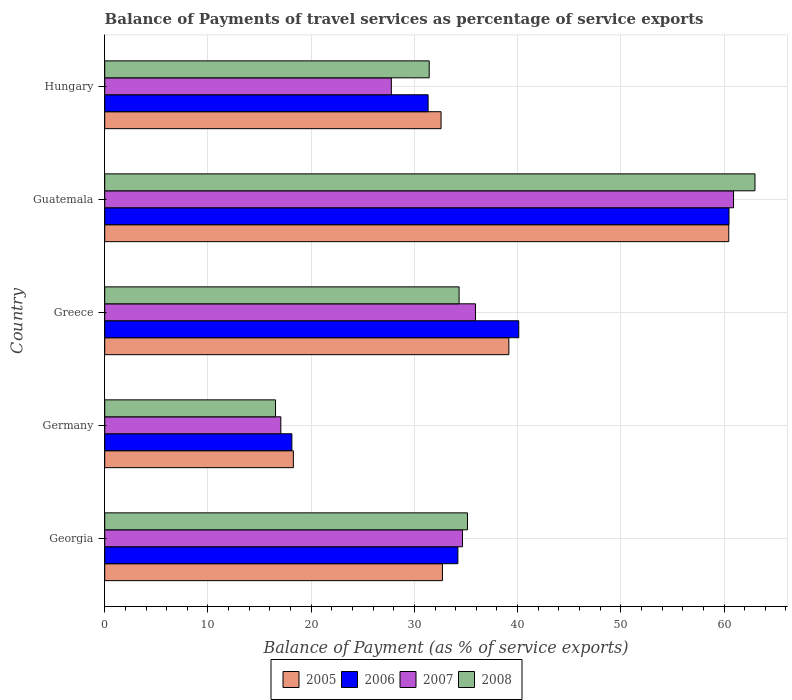Are the number of bars on each tick of the Y-axis equal?
Offer a terse response. Yes. What is the label of the 1st group of bars from the top?
Give a very brief answer. Hungary. In how many cases, is the number of bars for a given country not equal to the number of legend labels?
Your answer should be very brief. 0. What is the balance of payments of travel services in 2005 in Guatemala?
Your answer should be compact. 60.46. Across all countries, what is the maximum balance of payments of travel services in 2008?
Your answer should be compact. 63. Across all countries, what is the minimum balance of payments of travel services in 2008?
Ensure brevity in your answer.  16.55. In which country was the balance of payments of travel services in 2006 maximum?
Your answer should be very brief. Guatemala. What is the total balance of payments of travel services in 2006 in the graph?
Offer a very short reply. 184.28. What is the difference between the balance of payments of travel services in 2007 in Guatemala and that in Hungary?
Provide a short and direct response. 33.15. What is the difference between the balance of payments of travel services in 2005 in Greece and the balance of payments of travel services in 2008 in Hungary?
Ensure brevity in your answer.  7.72. What is the average balance of payments of travel services in 2008 per country?
Provide a short and direct response. 36.09. What is the difference between the balance of payments of travel services in 2008 and balance of payments of travel services in 2006 in Greece?
Ensure brevity in your answer.  -5.78. What is the ratio of the balance of payments of travel services in 2008 in Guatemala to that in Hungary?
Ensure brevity in your answer.  2. Is the difference between the balance of payments of travel services in 2008 in Greece and Guatemala greater than the difference between the balance of payments of travel services in 2006 in Greece and Guatemala?
Your answer should be compact. No. What is the difference between the highest and the second highest balance of payments of travel services in 2007?
Offer a very short reply. 25. What is the difference between the highest and the lowest balance of payments of travel services in 2008?
Provide a succinct answer. 46.45. In how many countries, is the balance of payments of travel services in 2008 greater than the average balance of payments of travel services in 2008 taken over all countries?
Make the answer very short. 1. Is the sum of the balance of payments of travel services in 2006 in Greece and Guatemala greater than the maximum balance of payments of travel services in 2008 across all countries?
Your answer should be very brief. Yes. Is it the case that in every country, the sum of the balance of payments of travel services in 2008 and balance of payments of travel services in 2005 is greater than the sum of balance of payments of travel services in 2007 and balance of payments of travel services in 2006?
Give a very brief answer. No. What does the 3rd bar from the bottom in Hungary represents?
Your response must be concise. 2007. How many bars are there?
Your response must be concise. 20. Are all the bars in the graph horizontal?
Ensure brevity in your answer.  Yes. What is the difference between two consecutive major ticks on the X-axis?
Give a very brief answer. 10. Are the values on the major ticks of X-axis written in scientific E-notation?
Provide a succinct answer. No. Where does the legend appear in the graph?
Make the answer very short. Bottom center. How many legend labels are there?
Offer a terse response. 4. What is the title of the graph?
Your answer should be compact. Balance of Payments of travel services as percentage of service exports. What is the label or title of the X-axis?
Offer a terse response. Balance of Payment (as % of service exports). What is the Balance of Payment (as % of service exports) in 2005 in Georgia?
Your answer should be very brief. 32.72. What is the Balance of Payment (as % of service exports) in 2006 in Georgia?
Your answer should be compact. 34.22. What is the Balance of Payment (as % of service exports) of 2007 in Georgia?
Offer a very short reply. 34.66. What is the Balance of Payment (as % of service exports) of 2008 in Georgia?
Offer a terse response. 35.15. What is the Balance of Payment (as % of service exports) in 2005 in Germany?
Keep it short and to the point. 18.28. What is the Balance of Payment (as % of service exports) of 2006 in Germany?
Make the answer very short. 18.13. What is the Balance of Payment (as % of service exports) of 2007 in Germany?
Offer a terse response. 17.06. What is the Balance of Payment (as % of service exports) in 2008 in Germany?
Offer a terse response. 16.55. What is the Balance of Payment (as % of service exports) of 2005 in Greece?
Your answer should be very brief. 39.16. What is the Balance of Payment (as % of service exports) of 2006 in Greece?
Keep it short and to the point. 40.11. What is the Balance of Payment (as % of service exports) of 2007 in Greece?
Your answer should be very brief. 35.92. What is the Balance of Payment (as % of service exports) in 2008 in Greece?
Ensure brevity in your answer.  34.33. What is the Balance of Payment (as % of service exports) in 2005 in Guatemala?
Keep it short and to the point. 60.46. What is the Balance of Payment (as % of service exports) in 2006 in Guatemala?
Your response must be concise. 60.48. What is the Balance of Payment (as % of service exports) of 2007 in Guatemala?
Your response must be concise. 60.92. What is the Balance of Payment (as % of service exports) in 2008 in Guatemala?
Provide a short and direct response. 63. What is the Balance of Payment (as % of service exports) of 2005 in Hungary?
Give a very brief answer. 32.59. What is the Balance of Payment (as % of service exports) of 2006 in Hungary?
Give a very brief answer. 31.33. What is the Balance of Payment (as % of service exports) in 2007 in Hungary?
Give a very brief answer. 27.77. What is the Balance of Payment (as % of service exports) in 2008 in Hungary?
Provide a short and direct response. 31.44. Across all countries, what is the maximum Balance of Payment (as % of service exports) of 2005?
Offer a terse response. 60.46. Across all countries, what is the maximum Balance of Payment (as % of service exports) in 2006?
Keep it short and to the point. 60.48. Across all countries, what is the maximum Balance of Payment (as % of service exports) in 2007?
Offer a terse response. 60.92. Across all countries, what is the maximum Balance of Payment (as % of service exports) of 2008?
Make the answer very short. 63. Across all countries, what is the minimum Balance of Payment (as % of service exports) in 2005?
Give a very brief answer. 18.28. Across all countries, what is the minimum Balance of Payment (as % of service exports) of 2006?
Offer a terse response. 18.13. Across all countries, what is the minimum Balance of Payment (as % of service exports) in 2007?
Keep it short and to the point. 17.06. Across all countries, what is the minimum Balance of Payment (as % of service exports) in 2008?
Your answer should be compact. 16.55. What is the total Balance of Payment (as % of service exports) of 2005 in the graph?
Offer a very short reply. 183.2. What is the total Balance of Payment (as % of service exports) in 2006 in the graph?
Keep it short and to the point. 184.28. What is the total Balance of Payment (as % of service exports) of 2007 in the graph?
Give a very brief answer. 176.34. What is the total Balance of Payment (as % of service exports) of 2008 in the graph?
Provide a succinct answer. 180.47. What is the difference between the Balance of Payment (as % of service exports) of 2005 in Georgia and that in Germany?
Offer a terse response. 14.44. What is the difference between the Balance of Payment (as % of service exports) in 2006 in Georgia and that in Germany?
Provide a short and direct response. 16.08. What is the difference between the Balance of Payment (as % of service exports) of 2007 in Georgia and that in Germany?
Offer a very short reply. 17.6. What is the difference between the Balance of Payment (as % of service exports) in 2008 in Georgia and that in Germany?
Ensure brevity in your answer.  18.6. What is the difference between the Balance of Payment (as % of service exports) in 2005 in Georgia and that in Greece?
Keep it short and to the point. -6.44. What is the difference between the Balance of Payment (as % of service exports) in 2006 in Georgia and that in Greece?
Keep it short and to the point. -5.9. What is the difference between the Balance of Payment (as % of service exports) of 2007 in Georgia and that in Greece?
Keep it short and to the point. -1.26. What is the difference between the Balance of Payment (as % of service exports) in 2008 in Georgia and that in Greece?
Make the answer very short. 0.81. What is the difference between the Balance of Payment (as % of service exports) in 2005 in Georgia and that in Guatemala?
Your answer should be compact. -27.74. What is the difference between the Balance of Payment (as % of service exports) of 2006 in Georgia and that in Guatemala?
Provide a succinct answer. -26.27. What is the difference between the Balance of Payment (as % of service exports) of 2007 in Georgia and that in Guatemala?
Your answer should be very brief. -26.26. What is the difference between the Balance of Payment (as % of service exports) of 2008 in Georgia and that in Guatemala?
Make the answer very short. -27.86. What is the difference between the Balance of Payment (as % of service exports) in 2005 in Georgia and that in Hungary?
Provide a short and direct response. 0.13. What is the difference between the Balance of Payment (as % of service exports) in 2006 in Georgia and that in Hungary?
Give a very brief answer. 2.88. What is the difference between the Balance of Payment (as % of service exports) of 2007 in Georgia and that in Hungary?
Provide a short and direct response. 6.89. What is the difference between the Balance of Payment (as % of service exports) of 2008 in Georgia and that in Hungary?
Ensure brevity in your answer.  3.71. What is the difference between the Balance of Payment (as % of service exports) in 2005 in Germany and that in Greece?
Give a very brief answer. -20.88. What is the difference between the Balance of Payment (as % of service exports) of 2006 in Germany and that in Greece?
Offer a very short reply. -21.98. What is the difference between the Balance of Payment (as % of service exports) of 2007 in Germany and that in Greece?
Offer a terse response. -18.86. What is the difference between the Balance of Payment (as % of service exports) of 2008 in Germany and that in Greece?
Provide a short and direct response. -17.78. What is the difference between the Balance of Payment (as % of service exports) in 2005 in Germany and that in Guatemala?
Give a very brief answer. -42.18. What is the difference between the Balance of Payment (as % of service exports) of 2006 in Germany and that in Guatemala?
Your answer should be very brief. -42.35. What is the difference between the Balance of Payment (as % of service exports) in 2007 in Germany and that in Guatemala?
Offer a very short reply. -43.86. What is the difference between the Balance of Payment (as % of service exports) of 2008 in Germany and that in Guatemala?
Your response must be concise. -46.45. What is the difference between the Balance of Payment (as % of service exports) in 2005 in Germany and that in Hungary?
Your answer should be very brief. -14.31. What is the difference between the Balance of Payment (as % of service exports) in 2006 in Germany and that in Hungary?
Provide a succinct answer. -13.2. What is the difference between the Balance of Payment (as % of service exports) of 2007 in Germany and that in Hungary?
Make the answer very short. -10.71. What is the difference between the Balance of Payment (as % of service exports) of 2008 in Germany and that in Hungary?
Your response must be concise. -14.89. What is the difference between the Balance of Payment (as % of service exports) in 2005 in Greece and that in Guatemala?
Your answer should be very brief. -21.31. What is the difference between the Balance of Payment (as % of service exports) of 2006 in Greece and that in Guatemala?
Provide a succinct answer. -20.37. What is the difference between the Balance of Payment (as % of service exports) of 2007 in Greece and that in Guatemala?
Provide a short and direct response. -25. What is the difference between the Balance of Payment (as % of service exports) in 2008 in Greece and that in Guatemala?
Give a very brief answer. -28.67. What is the difference between the Balance of Payment (as % of service exports) in 2005 in Greece and that in Hungary?
Make the answer very short. 6.57. What is the difference between the Balance of Payment (as % of service exports) in 2006 in Greece and that in Hungary?
Make the answer very short. 8.78. What is the difference between the Balance of Payment (as % of service exports) of 2007 in Greece and that in Hungary?
Provide a succinct answer. 8.15. What is the difference between the Balance of Payment (as % of service exports) in 2008 in Greece and that in Hungary?
Your answer should be very brief. 2.9. What is the difference between the Balance of Payment (as % of service exports) of 2005 in Guatemala and that in Hungary?
Your response must be concise. 27.87. What is the difference between the Balance of Payment (as % of service exports) of 2006 in Guatemala and that in Hungary?
Ensure brevity in your answer.  29.15. What is the difference between the Balance of Payment (as % of service exports) in 2007 in Guatemala and that in Hungary?
Provide a short and direct response. 33.15. What is the difference between the Balance of Payment (as % of service exports) of 2008 in Guatemala and that in Hungary?
Offer a very short reply. 31.56. What is the difference between the Balance of Payment (as % of service exports) in 2005 in Georgia and the Balance of Payment (as % of service exports) in 2006 in Germany?
Give a very brief answer. 14.59. What is the difference between the Balance of Payment (as % of service exports) in 2005 in Georgia and the Balance of Payment (as % of service exports) in 2007 in Germany?
Make the answer very short. 15.66. What is the difference between the Balance of Payment (as % of service exports) in 2005 in Georgia and the Balance of Payment (as % of service exports) in 2008 in Germany?
Your answer should be compact. 16.17. What is the difference between the Balance of Payment (as % of service exports) of 2006 in Georgia and the Balance of Payment (as % of service exports) of 2007 in Germany?
Give a very brief answer. 17.15. What is the difference between the Balance of Payment (as % of service exports) in 2006 in Georgia and the Balance of Payment (as % of service exports) in 2008 in Germany?
Your answer should be compact. 17.67. What is the difference between the Balance of Payment (as % of service exports) in 2007 in Georgia and the Balance of Payment (as % of service exports) in 2008 in Germany?
Offer a very short reply. 18.12. What is the difference between the Balance of Payment (as % of service exports) of 2005 in Georgia and the Balance of Payment (as % of service exports) of 2006 in Greece?
Offer a very short reply. -7.39. What is the difference between the Balance of Payment (as % of service exports) of 2005 in Georgia and the Balance of Payment (as % of service exports) of 2007 in Greece?
Give a very brief answer. -3.2. What is the difference between the Balance of Payment (as % of service exports) of 2005 in Georgia and the Balance of Payment (as % of service exports) of 2008 in Greece?
Your answer should be very brief. -1.61. What is the difference between the Balance of Payment (as % of service exports) of 2006 in Georgia and the Balance of Payment (as % of service exports) of 2007 in Greece?
Ensure brevity in your answer.  -1.7. What is the difference between the Balance of Payment (as % of service exports) of 2006 in Georgia and the Balance of Payment (as % of service exports) of 2008 in Greece?
Provide a short and direct response. -0.12. What is the difference between the Balance of Payment (as % of service exports) in 2007 in Georgia and the Balance of Payment (as % of service exports) in 2008 in Greece?
Ensure brevity in your answer.  0.33. What is the difference between the Balance of Payment (as % of service exports) of 2005 in Georgia and the Balance of Payment (as % of service exports) of 2006 in Guatemala?
Offer a very short reply. -27.76. What is the difference between the Balance of Payment (as % of service exports) of 2005 in Georgia and the Balance of Payment (as % of service exports) of 2007 in Guatemala?
Your response must be concise. -28.2. What is the difference between the Balance of Payment (as % of service exports) of 2005 in Georgia and the Balance of Payment (as % of service exports) of 2008 in Guatemala?
Ensure brevity in your answer.  -30.28. What is the difference between the Balance of Payment (as % of service exports) in 2006 in Georgia and the Balance of Payment (as % of service exports) in 2007 in Guatemala?
Provide a succinct answer. -26.71. What is the difference between the Balance of Payment (as % of service exports) of 2006 in Georgia and the Balance of Payment (as % of service exports) of 2008 in Guatemala?
Keep it short and to the point. -28.78. What is the difference between the Balance of Payment (as % of service exports) of 2007 in Georgia and the Balance of Payment (as % of service exports) of 2008 in Guatemala?
Provide a short and direct response. -28.34. What is the difference between the Balance of Payment (as % of service exports) in 2005 in Georgia and the Balance of Payment (as % of service exports) in 2006 in Hungary?
Your answer should be compact. 1.39. What is the difference between the Balance of Payment (as % of service exports) in 2005 in Georgia and the Balance of Payment (as % of service exports) in 2007 in Hungary?
Ensure brevity in your answer.  4.95. What is the difference between the Balance of Payment (as % of service exports) in 2005 in Georgia and the Balance of Payment (as % of service exports) in 2008 in Hungary?
Keep it short and to the point. 1.28. What is the difference between the Balance of Payment (as % of service exports) of 2006 in Georgia and the Balance of Payment (as % of service exports) of 2007 in Hungary?
Provide a short and direct response. 6.45. What is the difference between the Balance of Payment (as % of service exports) of 2006 in Georgia and the Balance of Payment (as % of service exports) of 2008 in Hungary?
Your answer should be very brief. 2.78. What is the difference between the Balance of Payment (as % of service exports) in 2007 in Georgia and the Balance of Payment (as % of service exports) in 2008 in Hungary?
Your response must be concise. 3.23. What is the difference between the Balance of Payment (as % of service exports) of 2005 in Germany and the Balance of Payment (as % of service exports) of 2006 in Greece?
Make the answer very short. -21.84. What is the difference between the Balance of Payment (as % of service exports) in 2005 in Germany and the Balance of Payment (as % of service exports) in 2007 in Greece?
Give a very brief answer. -17.64. What is the difference between the Balance of Payment (as % of service exports) in 2005 in Germany and the Balance of Payment (as % of service exports) in 2008 in Greece?
Give a very brief answer. -16.06. What is the difference between the Balance of Payment (as % of service exports) of 2006 in Germany and the Balance of Payment (as % of service exports) of 2007 in Greece?
Keep it short and to the point. -17.79. What is the difference between the Balance of Payment (as % of service exports) of 2006 in Germany and the Balance of Payment (as % of service exports) of 2008 in Greece?
Provide a succinct answer. -16.2. What is the difference between the Balance of Payment (as % of service exports) of 2007 in Germany and the Balance of Payment (as % of service exports) of 2008 in Greece?
Make the answer very short. -17.27. What is the difference between the Balance of Payment (as % of service exports) of 2005 in Germany and the Balance of Payment (as % of service exports) of 2006 in Guatemala?
Your response must be concise. -42.21. What is the difference between the Balance of Payment (as % of service exports) in 2005 in Germany and the Balance of Payment (as % of service exports) in 2007 in Guatemala?
Provide a succinct answer. -42.65. What is the difference between the Balance of Payment (as % of service exports) in 2005 in Germany and the Balance of Payment (as % of service exports) in 2008 in Guatemala?
Offer a very short reply. -44.72. What is the difference between the Balance of Payment (as % of service exports) in 2006 in Germany and the Balance of Payment (as % of service exports) in 2007 in Guatemala?
Offer a terse response. -42.79. What is the difference between the Balance of Payment (as % of service exports) in 2006 in Germany and the Balance of Payment (as % of service exports) in 2008 in Guatemala?
Offer a terse response. -44.87. What is the difference between the Balance of Payment (as % of service exports) of 2007 in Germany and the Balance of Payment (as % of service exports) of 2008 in Guatemala?
Offer a very short reply. -45.94. What is the difference between the Balance of Payment (as % of service exports) of 2005 in Germany and the Balance of Payment (as % of service exports) of 2006 in Hungary?
Offer a terse response. -13.06. What is the difference between the Balance of Payment (as % of service exports) of 2005 in Germany and the Balance of Payment (as % of service exports) of 2007 in Hungary?
Provide a short and direct response. -9.49. What is the difference between the Balance of Payment (as % of service exports) in 2005 in Germany and the Balance of Payment (as % of service exports) in 2008 in Hungary?
Offer a terse response. -13.16. What is the difference between the Balance of Payment (as % of service exports) of 2006 in Germany and the Balance of Payment (as % of service exports) of 2007 in Hungary?
Your response must be concise. -9.64. What is the difference between the Balance of Payment (as % of service exports) in 2006 in Germany and the Balance of Payment (as % of service exports) in 2008 in Hungary?
Keep it short and to the point. -13.31. What is the difference between the Balance of Payment (as % of service exports) of 2007 in Germany and the Balance of Payment (as % of service exports) of 2008 in Hungary?
Provide a succinct answer. -14.38. What is the difference between the Balance of Payment (as % of service exports) in 2005 in Greece and the Balance of Payment (as % of service exports) in 2006 in Guatemala?
Keep it short and to the point. -21.33. What is the difference between the Balance of Payment (as % of service exports) of 2005 in Greece and the Balance of Payment (as % of service exports) of 2007 in Guatemala?
Keep it short and to the point. -21.77. What is the difference between the Balance of Payment (as % of service exports) of 2005 in Greece and the Balance of Payment (as % of service exports) of 2008 in Guatemala?
Keep it short and to the point. -23.84. What is the difference between the Balance of Payment (as % of service exports) of 2006 in Greece and the Balance of Payment (as % of service exports) of 2007 in Guatemala?
Provide a succinct answer. -20.81. What is the difference between the Balance of Payment (as % of service exports) in 2006 in Greece and the Balance of Payment (as % of service exports) in 2008 in Guatemala?
Your answer should be compact. -22.89. What is the difference between the Balance of Payment (as % of service exports) in 2007 in Greece and the Balance of Payment (as % of service exports) in 2008 in Guatemala?
Provide a short and direct response. -27.08. What is the difference between the Balance of Payment (as % of service exports) in 2005 in Greece and the Balance of Payment (as % of service exports) in 2006 in Hungary?
Your answer should be compact. 7.82. What is the difference between the Balance of Payment (as % of service exports) of 2005 in Greece and the Balance of Payment (as % of service exports) of 2007 in Hungary?
Give a very brief answer. 11.39. What is the difference between the Balance of Payment (as % of service exports) in 2005 in Greece and the Balance of Payment (as % of service exports) in 2008 in Hungary?
Give a very brief answer. 7.72. What is the difference between the Balance of Payment (as % of service exports) in 2006 in Greece and the Balance of Payment (as % of service exports) in 2007 in Hungary?
Keep it short and to the point. 12.34. What is the difference between the Balance of Payment (as % of service exports) in 2006 in Greece and the Balance of Payment (as % of service exports) in 2008 in Hungary?
Offer a terse response. 8.68. What is the difference between the Balance of Payment (as % of service exports) of 2007 in Greece and the Balance of Payment (as % of service exports) of 2008 in Hungary?
Provide a succinct answer. 4.48. What is the difference between the Balance of Payment (as % of service exports) in 2005 in Guatemala and the Balance of Payment (as % of service exports) in 2006 in Hungary?
Your response must be concise. 29.13. What is the difference between the Balance of Payment (as % of service exports) in 2005 in Guatemala and the Balance of Payment (as % of service exports) in 2007 in Hungary?
Make the answer very short. 32.69. What is the difference between the Balance of Payment (as % of service exports) of 2005 in Guatemala and the Balance of Payment (as % of service exports) of 2008 in Hungary?
Your answer should be compact. 29.02. What is the difference between the Balance of Payment (as % of service exports) in 2006 in Guatemala and the Balance of Payment (as % of service exports) in 2007 in Hungary?
Make the answer very short. 32.71. What is the difference between the Balance of Payment (as % of service exports) of 2006 in Guatemala and the Balance of Payment (as % of service exports) of 2008 in Hungary?
Provide a succinct answer. 29.05. What is the difference between the Balance of Payment (as % of service exports) in 2007 in Guatemala and the Balance of Payment (as % of service exports) in 2008 in Hungary?
Ensure brevity in your answer.  29.49. What is the average Balance of Payment (as % of service exports) in 2005 per country?
Provide a succinct answer. 36.64. What is the average Balance of Payment (as % of service exports) of 2006 per country?
Offer a very short reply. 36.86. What is the average Balance of Payment (as % of service exports) of 2007 per country?
Your answer should be very brief. 35.27. What is the average Balance of Payment (as % of service exports) of 2008 per country?
Ensure brevity in your answer.  36.09. What is the difference between the Balance of Payment (as % of service exports) of 2005 and Balance of Payment (as % of service exports) of 2006 in Georgia?
Provide a short and direct response. -1.5. What is the difference between the Balance of Payment (as % of service exports) of 2005 and Balance of Payment (as % of service exports) of 2007 in Georgia?
Your response must be concise. -1.94. What is the difference between the Balance of Payment (as % of service exports) in 2005 and Balance of Payment (as % of service exports) in 2008 in Georgia?
Your answer should be compact. -2.43. What is the difference between the Balance of Payment (as % of service exports) in 2006 and Balance of Payment (as % of service exports) in 2007 in Georgia?
Ensure brevity in your answer.  -0.45. What is the difference between the Balance of Payment (as % of service exports) in 2006 and Balance of Payment (as % of service exports) in 2008 in Georgia?
Provide a short and direct response. -0.93. What is the difference between the Balance of Payment (as % of service exports) of 2007 and Balance of Payment (as % of service exports) of 2008 in Georgia?
Your answer should be very brief. -0.48. What is the difference between the Balance of Payment (as % of service exports) in 2005 and Balance of Payment (as % of service exports) in 2006 in Germany?
Your answer should be very brief. 0.14. What is the difference between the Balance of Payment (as % of service exports) in 2005 and Balance of Payment (as % of service exports) in 2007 in Germany?
Provide a succinct answer. 1.21. What is the difference between the Balance of Payment (as % of service exports) of 2005 and Balance of Payment (as % of service exports) of 2008 in Germany?
Provide a short and direct response. 1.73. What is the difference between the Balance of Payment (as % of service exports) in 2006 and Balance of Payment (as % of service exports) in 2007 in Germany?
Provide a short and direct response. 1.07. What is the difference between the Balance of Payment (as % of service exports) of 2006 and Balance of Payment (as % of service exports) of 2008 in Germany?
Offer a terse response. 1.58. What is the difference between the Balance of Payment (as % of service exports) in 2007 and Balance of Payment (as % of service exports) in 2008 in Germany?
Give a very brief answer. 0.51. What is the difference between the Balance of Payment (as % of service exports) of 2005 and Balance of Payment (as % of service exports) of 2006 in Greece?
Provide a short and direct response. -0.96. What is the difference between the Balance of Payment (as % of service exports) in 2005 and Balance of Payment (as % of service exports) in 2007 in Greece?
Provide a short and direct response. 3.23. What is the difference between the Balance of Payment (as % of service exports) of 2005 and Balance of Payment (as % of service exports) of 2008 in Greece?
Provide a short and direct response. 4.82. What is the difference between the Balance of Payment (as % of service exports) in 2006 and Balance of Payment (as % of service exports) in 2007 in Greece?
Ensure brevity in your answer.  4.19. What is the difference between the Balance of Payment (as % of service exports) in 2006 and Balance of Payment (as % of service exports) in 2008 in Greece?
Provide a succinct answer. 5.78. What is the difference between the Balance of Payment (as % of service exports) in 2007 and Balance of Payment (as % of service exports) in 2008 in Greece?
Ensure brevity in your answer.  1.59. What is the difference between the Balance of Payment (as % of service exports) in 2005 and Balance of Payment (as % of service exports) in 2006 in Guatemala?
Provide a succinct answer. -0.02. What is the difference between the Balance of Payment (as % of service exports) in 2005 and Balance of Payment (as % of service exports) in 2007 in Guatemala?
Your response must be concise. -0.46. What is the difference between the Balance of Payment (as % of service exports) in 2005 and Balance of Payment (as % of service exports) in 2008 in Guatemala?
Your answer should be very brief. -2.54. What is the difference between the Balance of Payment (as % of service exports) in 2006 and Balance of Payment (as % of service exports) in 2007 in Guatemala?
Your response must be concise. -0.44. What is the difference between the Balance of Payment (as % of service exports) of 2006 and Balance of Payment (as % of service exports) of 2008 in Guatemala?
Provide a short and direct response. -2.52. What is the difference between the Balance of Payment (as % of service exports) in 2007 and Balance of Payment (as % of service exports) in 2008 in Guatemala?
Offer a terse response. -2.08. What is the difference between the Balance of Payment (as % of service exports) in 2005 and Balance of Payment (as % of service exports) in 2006 in Hungary?
Your answer should be very brief. 1.25. What is the difference between the Balance of Payment (as % of service exports) in 2005 and Balance of Payment (as % of service exports) in 2007 in Hungary?
Offer a very short reply. 4.82. What is the difference between the Balance of Payment (as % of service exports) in 2005 and Balance of Payment (as % of service exports) in 2008 in Hungary?
Provide a short and direct response. 1.15. What is the difference between the Balance of Payment (as % of service exports) in 2006 and Balance of Payment (as % of service exports) in 2007 in Hungary?
Provide a short and direct response. 3.56. What is the difference between the Balance of Payment (as % of service exports) in 2006 and Balance of Payment (as % of service exports) in 2008 in Hungary?
Offer a very short reply. -0.1. What is the difference between the Balance of Payment (as % of service exports) in 2007 and Balance of Payment (as % of service exports) in 2008 in Hungary?
Make the answer very short. -3.67. What is the ratio of the Balance of Payment (as % of service exports) in 2005 in Georgia to that in Germany?
Your response must be concise. 1.79. What is the ratio of the Balance of Payment (as % of service exports) in 2006 in Georgia to that in Germany?
Your response must be concise. 1.89. What is the ratio of the Balance of Payment (as % of service exports) of 2007 in Georgia to that in Germany?
Give a very brief answer. 2.03. What is the ratio of the Balance of Payment (as % of service exports) of 2008 in Georgia to that in Germany?
Your answer should be very brief. 2.12. What is the ratio of the Balance of Payment (as % of service exports) in 2005 in Georgia to that in Greece?
Your answer should be compact. 0.84. What is the ratio of the Balance of Payment (as % of service exports) in 2006 in Georgia to that in Greece?
Provide a short and direct response. 0.85. What is the ratio of the Balance of Payment (as % of service exports) in 2007 in Georgia to that in Greece?
Keep it short and to the point. 0.96. What is the ratio of the Balance of Payment (as % of service exports) of 2008 in Georgia to that in Greece?
Offer a terse response. 1.02. What is the ratio of the Balance of Payment (as % of service exports) in 2005 in Georgia to that in Guatemala?
Ensure brevity in your answer.  0.54. What is the ratio of the Balance of Payment (as % of service exports) of 2006 in Georgia to that in Guatemala?
Make the answer very short. 0.57. What is the ratio of the Balance of Payment (as % of service exports) in 2007 in Georgia to that in Guatemala?
Your answer should be compact. 0.57. What is the ratio of the Balance of Payment (as % of service exports) of 2008 in Georgia to that in Guatemala?
Offer a very short reply. 0.56. What is the ratio of the Balance of Payment (as % of service exports) in 2006 in Georgia to that in Hungary?
Offer a terse response. 1.09. What is the ratio of the Balance of Payment (as % of service exports) of 2007 in Georgia to that in Hungary?
Keep it short and to the point. 1.25. What is the ratio of the Balance of Payment (as % of service exports) in 2008 in Georgia to that in Hungary?
Provide a short and direct response. 1.12. What is the ratio of the Balance of Payment (as % of service exports) in 2005 in Germany to that in Greece?
Offer a terse response. 0.47. What is the ratio of the Balance of Payment (as % of service exports) in 2006 in Germany to that in Greece?
Offer a terse response. 0.45. What is the ratio of the Balance of Payment (as % of service exports) in 2007 in Germany to that in Greece?
Make the answer very short. 0.47. What is the ratio of the Balance of Payment (as % of service exports) in 2008 in Germany to that in Greece?
Give a very brief answer. 0.48. What is the ratio of the Balance of Payment (as % of service exports) in 2005 in Germany to that in Guatemala?
Your response must be concise. 0.3. What is the ratio of the Balance of Payment (as % of service exports) of 2006 in Germany to that in Guatemala?
Your answer should be compact. 0.3. What is the ratio of the Balance of Payment (as % of service exports) in 2007 in Germany to that in Guatemala?
Your response must be concise. 0.28. What is the ratio of the Balance of Payment (as % of service exports) of 2008 in Germany to that in Guatemala?
Offer a terse response. 0.26. What is the ratio of the Balance of Payment (as % of service exports) in 2005 in Germany to that in Hungary?
Make the answer very short. 0.56. What is the ratio of the Balance of Payment (as % of service exports) in 2006 in Germany to that in Hungary?
Keep it short and to the point. 0.58. What is the ratio of the Balance of Payment (as % of service exports) in 2007 in Germany to that in Hungary?
Offer a very short reply. 0.61. What is the ratio of the Balance of Payment (as % of service exports) in 2008 in Germany to that in Hungary?
Your answer should be very brief. 0.53. What is the ratio of the Balance of Payment (as % of service exports) of 2005 in Greece to that in Guatemala?
Offer a terse response. 0.65. What is the ratio of the Balance of Payment (as % of service exports) in 2006 in Greece to that in Guatemala?
Provide a succinct answer. 0.66. What is the ratio of the Balance of Payment (as % of service exports) in 2007 in Greece to that in Guatemala?
Provide a short and direct response. 0.59. What is the ratio of the Balance of Payment (as % of service exports) in 2008 in Greece to that in Guatemala?
Make the answer very short. 0.55. What is the ratio of the Balance of Payment (as % of service exports) of 2005 in Greece to that in Hungary?
Your answer should be very brief. 1.2. What is the ratio of the Balance of Payment (as % of service exports) of 2006 in Greece to that in Hungary?
Provide a succinct answer. 1.28. What is the ratio of the Balance of Payment (as % of service exports) in 2007 in Greece to that in Hungary?
Your answer should be compact. 1.29. What is the ratio of the Balance of Payment (as % of service exports) of 2008 in Greece to that in Hungary?
Your answer should be very brief. 1.09. What is the ratio of the Balance of Payment (as % of service exports) of 2005 in Guatemala to that in Hungary?
Ensure brevity in your answer.  1.86. What is the ratio of the Balance of Payment (as % of service exports) in 2006 in Guatemala to that in Hungary?
Ensure brevity in your answer.  1.93. What is the ratio of the Balance of Payment (as % of service exports) in 2007 in Guatemala to that in Hungary?
Provide a succinct answer. 2.19. What is the ratio of the Balance of Payment (as % of service exports) of 2008 in Guatemala to that in Hungary?
Provide a short and direct response. 2. What is the difference between the highest and the second highest Balance of Payment (as % of service exports) in 2005?
Your response must be concise. 21.31. What is the difference between the highest and the second highest Balance of Payment (as % of service exports) in 2006?
Your answer should be compact. 20.37. What is the difference between the highest and the second highest Balance of Payment (as % of service exports) in 2007?
Your response must be concise. 25. What is the difference between the highest and the second highest Balance of Payment (as % of service exports) in 2008?
Offer a very short reply. 27.86. What is the difference between the highest and the lowest Balance of Payment (as % of service exports) in 2005?
Your answer should be compact. 42.18. What is the difference between the highest and the lowest Balance of Payment (as % of service exports) of 2006?
Keep it short and to the point. 42.35. What is the difference between the highest and the lowest Balance of Payment (as % of service exports) of 2007?
Your response must be concise. 43.86. What is the difference between the highest and the lowest Balance of Payment (as % of service exports) in 2008?
Give a very brief answer. 46.45. 